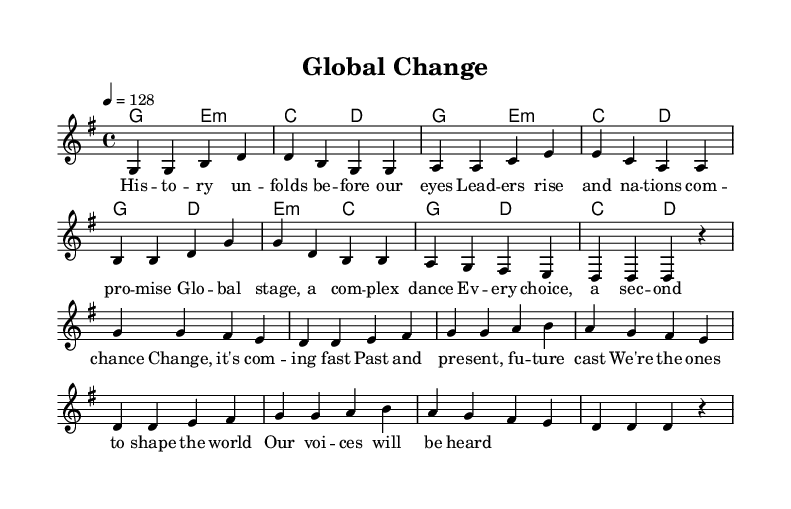What is the key signature of this music? The key signature is G major, which has one sharp (F#).
Answer: G major What is the time signature of this piece? The time signature is indicated as 4/4, meaning there are four beats in each measure.
Answer: 4/4 What is the tempo marking of the piece? The tempo marking states 4 = 128, indicating the quarter note gets 128 beats per minute.
Answer: 128 How many measures are in the verse section? The verse section is composed of eight measures, as evidenced by the grouping of the notes and chords.
Answer: 8 In which section do the lyrics mention "Global stage"? The phrase "Global stage" is found in the verse section, where the lyrics narrate historical events and leadership.
Answer: Verse How many musical sections does the piece contain? The piece contains two notable sections: a verse and a chorus, each with distinct melodic and lyrical content.
Answer: 2 What is the overall mood expressed in the chorus lyrics? The chorus lyrics convey a sense of urgency and empowerment, suggesting an optimistic outlook on change and influence.
Answer: Empowering 